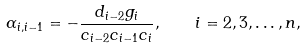Convert formula to latex. <formula><loc_0><loc_0><loc_500><loc_500>\alpha _ { i , i - 1 } = - \frac { d _ { i - 2 } g _ { i } } { c _ { i - 2 } c _ { i - 1 } c _ { i } } , \quad i = 2 , 3 , \dots , n ,</formula> 